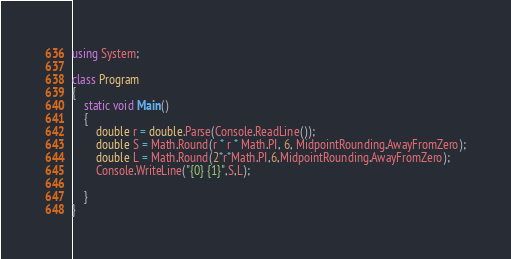<code> <loc_0><loc_0><loc_500><loc_500><_C#_>using System;

class Program
{
    static void Main()
    {
        double r = double.Parse(Console.ReadLine());
        double S = Math.Round(r * r * Math.PI, 6, MidpointRounding.AwayFromZero);
        double L = Math.Round(2*r*Math.PI,6,MidpointRounding.AwayFromZero);
        Console.WriteLine("{0} {1}",S,L);

    }
}</code> 